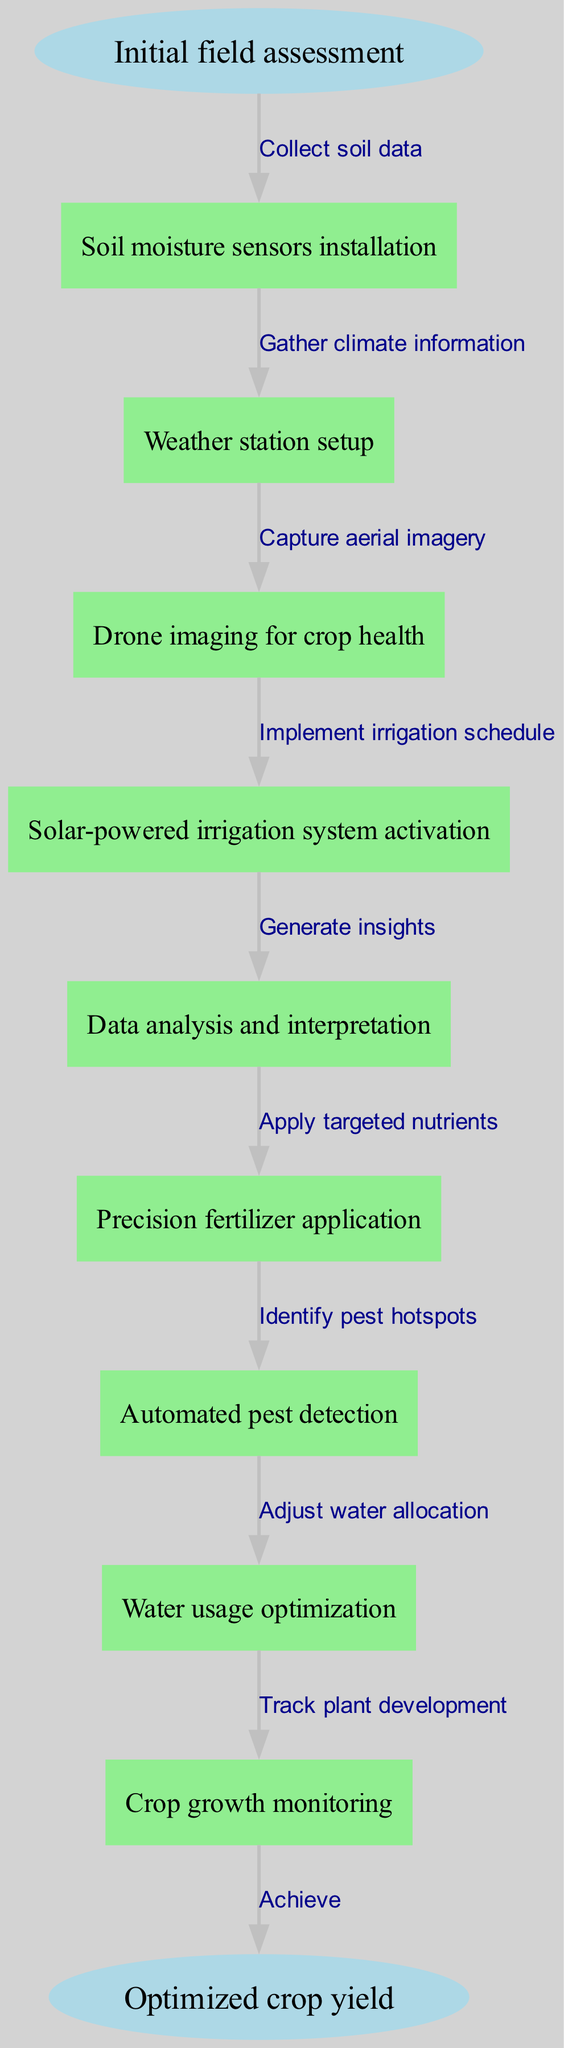What is the first step in the crop yield optimization process? The diagram shows "Initial field assessment" as the starting point.
Answer: Initial field assessment How many nodes are present in the diagram? There are 9 nodes listed in the diagram, including the start and end points.
Answer: 9 What is the last node before reaching the endpoint? Tracing the flow, the last node is "Crop growth monitoring," which leads to the end point of optimized crop yield.
Answer: Crop growth monitoring What edge follows the "Drone imaging for crop health" node? From the diagram, after "Drone imaging for crop health," the next edge is "Implement irrigation schedule."
Answer: Implement irrigation schedule What is the second node in the process? Counting from the start point, the second node after "Initial field assessment" is "Soil moisture sensors installation."
Answer: Soil moisture sensors installation Which node focuses on climate information collection? The node that emphasizes gathering climate information is "Weather station setup."
Answer: Weather station setup How many edges connect the nodes in the process? The diagram indicates there are 8 edges that connect the 9 nodes throughout the process.
Answer: 8 What node involves the application of nutrients? The node dedicated to applying targeted nutrients in the process is "Precision fertilizer application."
Answer: Precision fertilizer application What must be monitored after "Water usage optimization"? The flow indicates "Crop growth monitoring" immediately follows "Water usage optimization."
Answer: Crop growth monitoring 